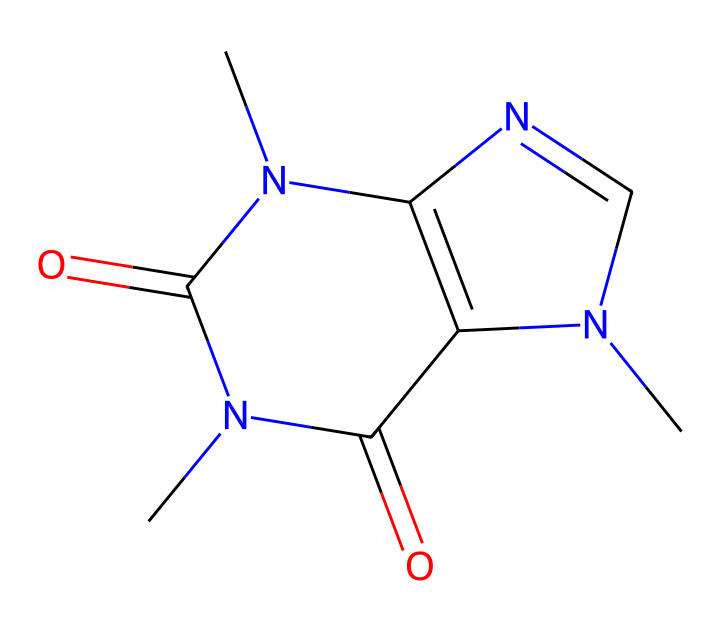how many nitrogen atoms are in the caffeine structure? Examining the SMILES representation, we can count the number of nitrogen atoms represented by 'N' in the structure. In this case, there are three 'N' indicating three nitrogen atoms.
Answer: three what is the molecular formula of caffeine based on this structure? The SMILES provides information about the atoms present. Adding up the elements, we find they consist of carbon (C), hydrogen (H), nitrogen (N), and oxygen (O). The counts give us the molecular formula: C8H10N4O2.
Answer: C8H10N4O2 does this structure exhibit geometric isomerism? To determine if this compound exhibits geometric isomerism, we check for the presence of double bonds and the corresponding substituents. The presence of double bonds in the bicyclic structure suggests it can have cis and trans forms, thus allowing for geometric isomerism.
Answer: yes what is the relationship between caffeine and its geometric isomers? Caffeine has a specific structure; its geometric isomers would differ in the arrangement of atoms around the double bonds while maintaining the same molecular formula. This can affect its properties and biological activity.
Answer: structural variability which functional groups are present in caffeine? By reviewing the structure from SMILES, we notice carbonyl (C=O) and amine (N-H) groups in the structure. These functional groups play a significant role in the chemical's reactivity and properties.
Answer: amine, carbonyl 